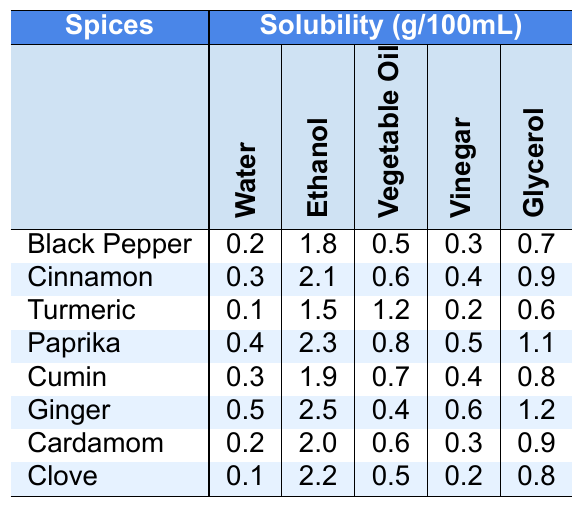What is the solubility of Ginger in Ethanol? The table indicates that the solubility of Ginger in Ethanol is listed under the Ethanol column for Ginger, which shows a value of 2.5 g/100mL.
Answer: 2.5 Which spice has the highest solubility in Water? By comparing the solubility values in the Water column, Paprika has the highest value of 0.4 g/100mL, which is greater than the other spices listed.
Answer: Paprika Is there a spice that is completely insoluble in all solvents listed? The table shows solubility values for all spices in each solvent, meaning no spice is completely insoluble in all the listed solvents.
Answer: No What is the total solubility of Cumin in Water and Glycerol combined? First, find the solubility of Cumin in Water (0.3 g/100mL) and in Glycerol (0.8 g/100mL). Then sum these values: 0.3 + 0.8 = 1.1 g/100mL.
Answer: 1.1 What is the difference in solubility between Cinnamon and Clove in Ethanol? The solubility of Cinnamon in Ethanol is 2.1 g/100mL, while that for Clove is 2.2 g/100mL. The difference is 2.2 - 2.1 = 0.1 g/100mL.
Answer: 0.1 Which solvent generally dissolves spices better based on the provided solubility values? To determine this, we can look at the average solubility of all spices in each solvent. Summing the solubility values for each solvent and dividing by the number of spices shows Ethanol has the highest average solubility (average of 1.8 g/100mL).
Answer: Ethanol Is the solubility of Paprika in Glycerol greater than that of Turmeric in Vegetable Oil? Paprika's solubility in Glycerol is 1.1 g/100mL, while Turmeric’s in Vegetable Oil is 1.2 g/100mL. Since 1.1 < 1.2, Paprika's solubility is not greater.
Answer: No Which spice has the lowest overall solubility when averaged across all solvents? To find this, calculate the average solubility for each spice: Black Pepper (0.5), Cinnamon (0.9), Turmeric (0.5), Paprika (0.82), Cumin (0.62), Ginger (0.74), Cardamom (0.62), Clove (0.62). Both Clove and Turmeric share the lowest average of 0.5 g/100mL.
Answer: Turmeric and Clove What is the maximum solubility of Cinnamon among all the solvents? The maximum solubility of Cinnamon can be found by checking all values: Water (0.3), Ethanol (2.1), Vegetable Oil (0.6), Vinegar (0.4), Glycerol (0.9). The highest is 2.1 g/100mL in Ethanol.
Answer: 2.1 What is the average solubility of all spices in Glycerol? First, sum the solubility of each spice in Glycerol: 0.7 + 0.9 + 0.6 + 1.1 + 0.8 + 1.2 + 0.9 + 0.8 = 6.0 g/100mL. Dividing by the number of spices (8) gives an average of 6.0 / 8 = 0.75 g/100mL.
Answer: 0.75 